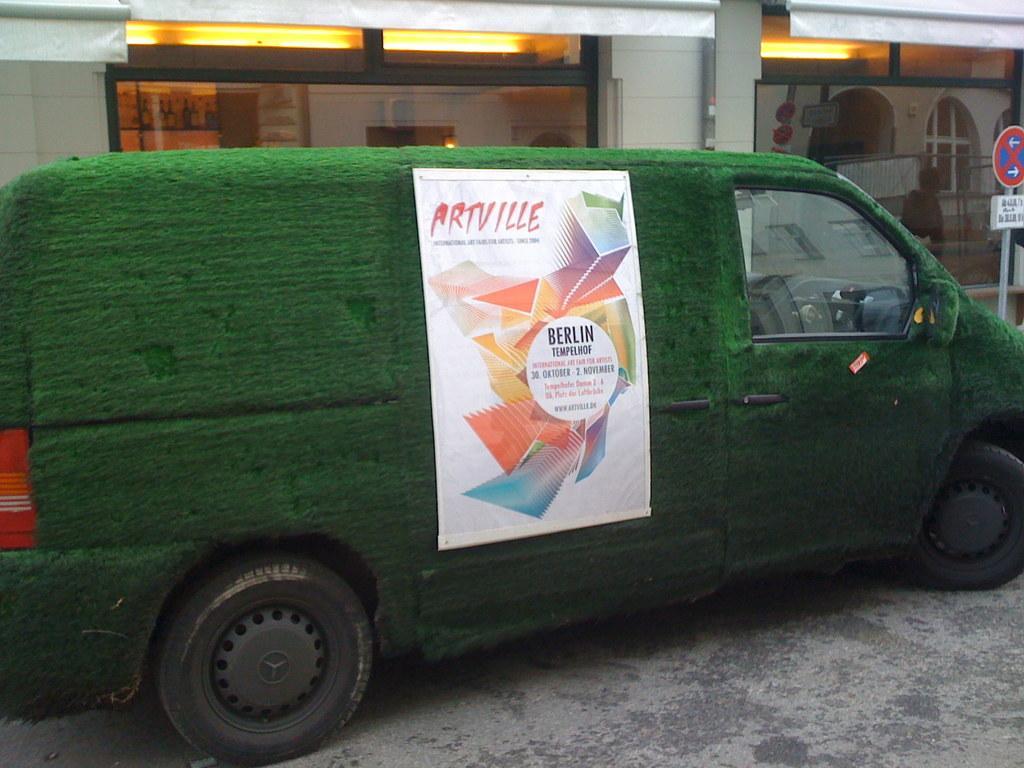How would you summarize this image in a sentence or two? In this picture we can see green color truck. Here we can see poster on the truck. On the back we can see glass door, lights and other objects. Here we can see a pipe near to the door. On the right there is a man who is walking near to the sign board. 